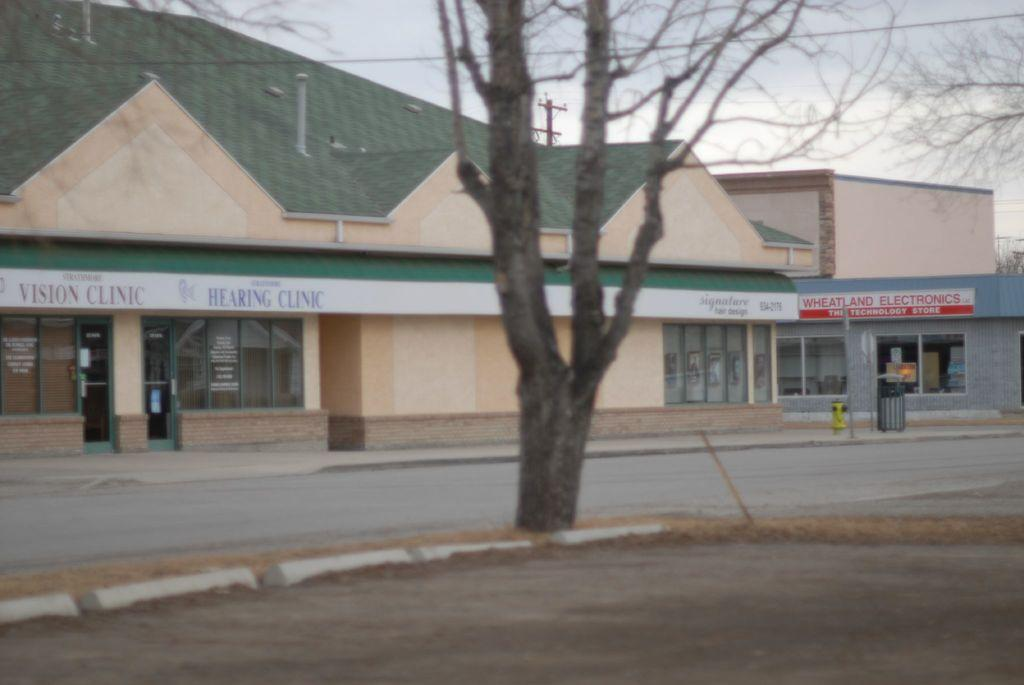What is the primary surface visible in the image? There is a ground in the image. What can be seen on the ground in the image? There is an object in the image. What is used for waste disposal in the image? There is a dustbin in the image. What type of structures are present in the image? There are buildings in the image. What type of vegetation is present in the image? There are trees in the image. What is located in the background of the image? There is an electric pole and the sky is visible in the background of the image. How many bombs can be seen in the image? There are no bombs present in the image. What type of bird is sitting on the electric pole in the image? There is no bird present on the electric pole in the image. 